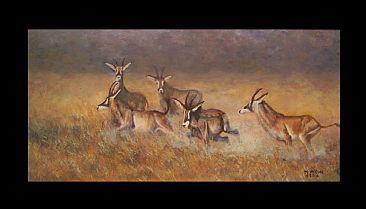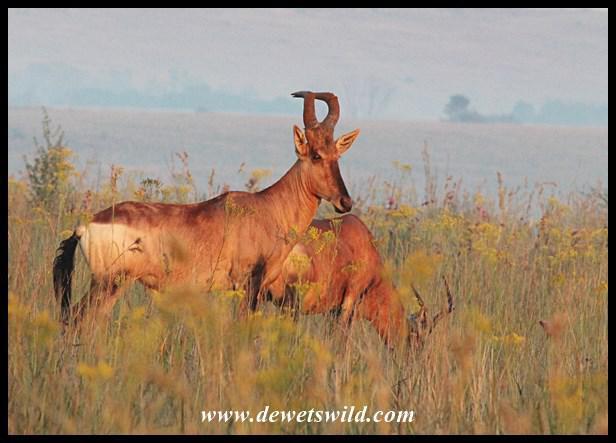The first image is the image on the left, the second image is the image on the right. For the images shown, is this caption "The left image includes more than twice the number of horned animals as the right image." true? Answer yes or no. Yes. The first image is the image on the left, the second image is the image on the right. Given the left and right images, does the statement "There is exactly one animal standing in the right image." hold true? Answer yes or no. No. 